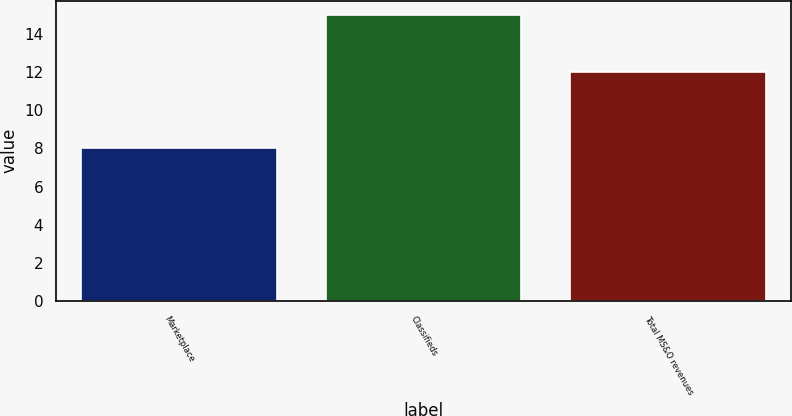Convert chart to OTSL. <chart><loc_0><loc_0><loc_500><loc_500><bar_chart><fcel>Marketplace<fcel>Classifieds<fcel>Total MS&O revenues<nl><fcel>8<fcel>15<fcel>12<nl></chart> 